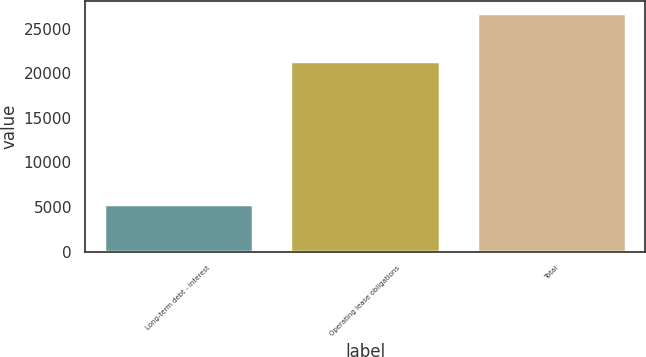<chart> <loc_0><loc_0><loc_500><loc_500><bar_chart><fcel>Long-term debt - interest<fcel>Operating lease obligations<fcel>Total<nl><fcel>5391<fcel>21366<fcel>26757<nl></chart> 